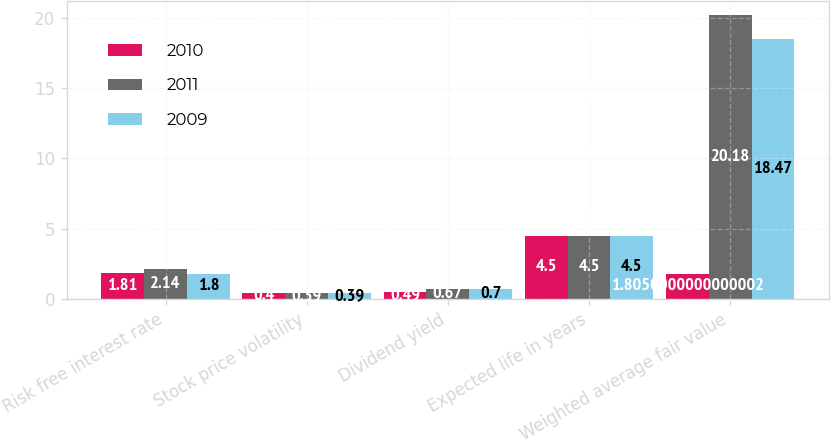<chart> <loc_0><loc_0><loc_500><loc_500><stacked_bar_chart><ecel><fcel>Risk free interest rate<fcel>Stock price volatility<fcel>Dividend yield<fcel>Expected life in years<fcel>Weighted average fair value<nl><fcel>2010<fcel>1.81<fcel>0.4<fcel>0.49<fcel>4.5<fcel>1.805<nl><fcel>2011<fcel>2.14<fcel>0.39<fcel>0.67<fcel>4.5<fcel>20.18<nl><fcel>2009<fcel>1.8<fcel>0.39<fcel>0.7<fcel>4.5<fcel>18.47<nl></chart> 